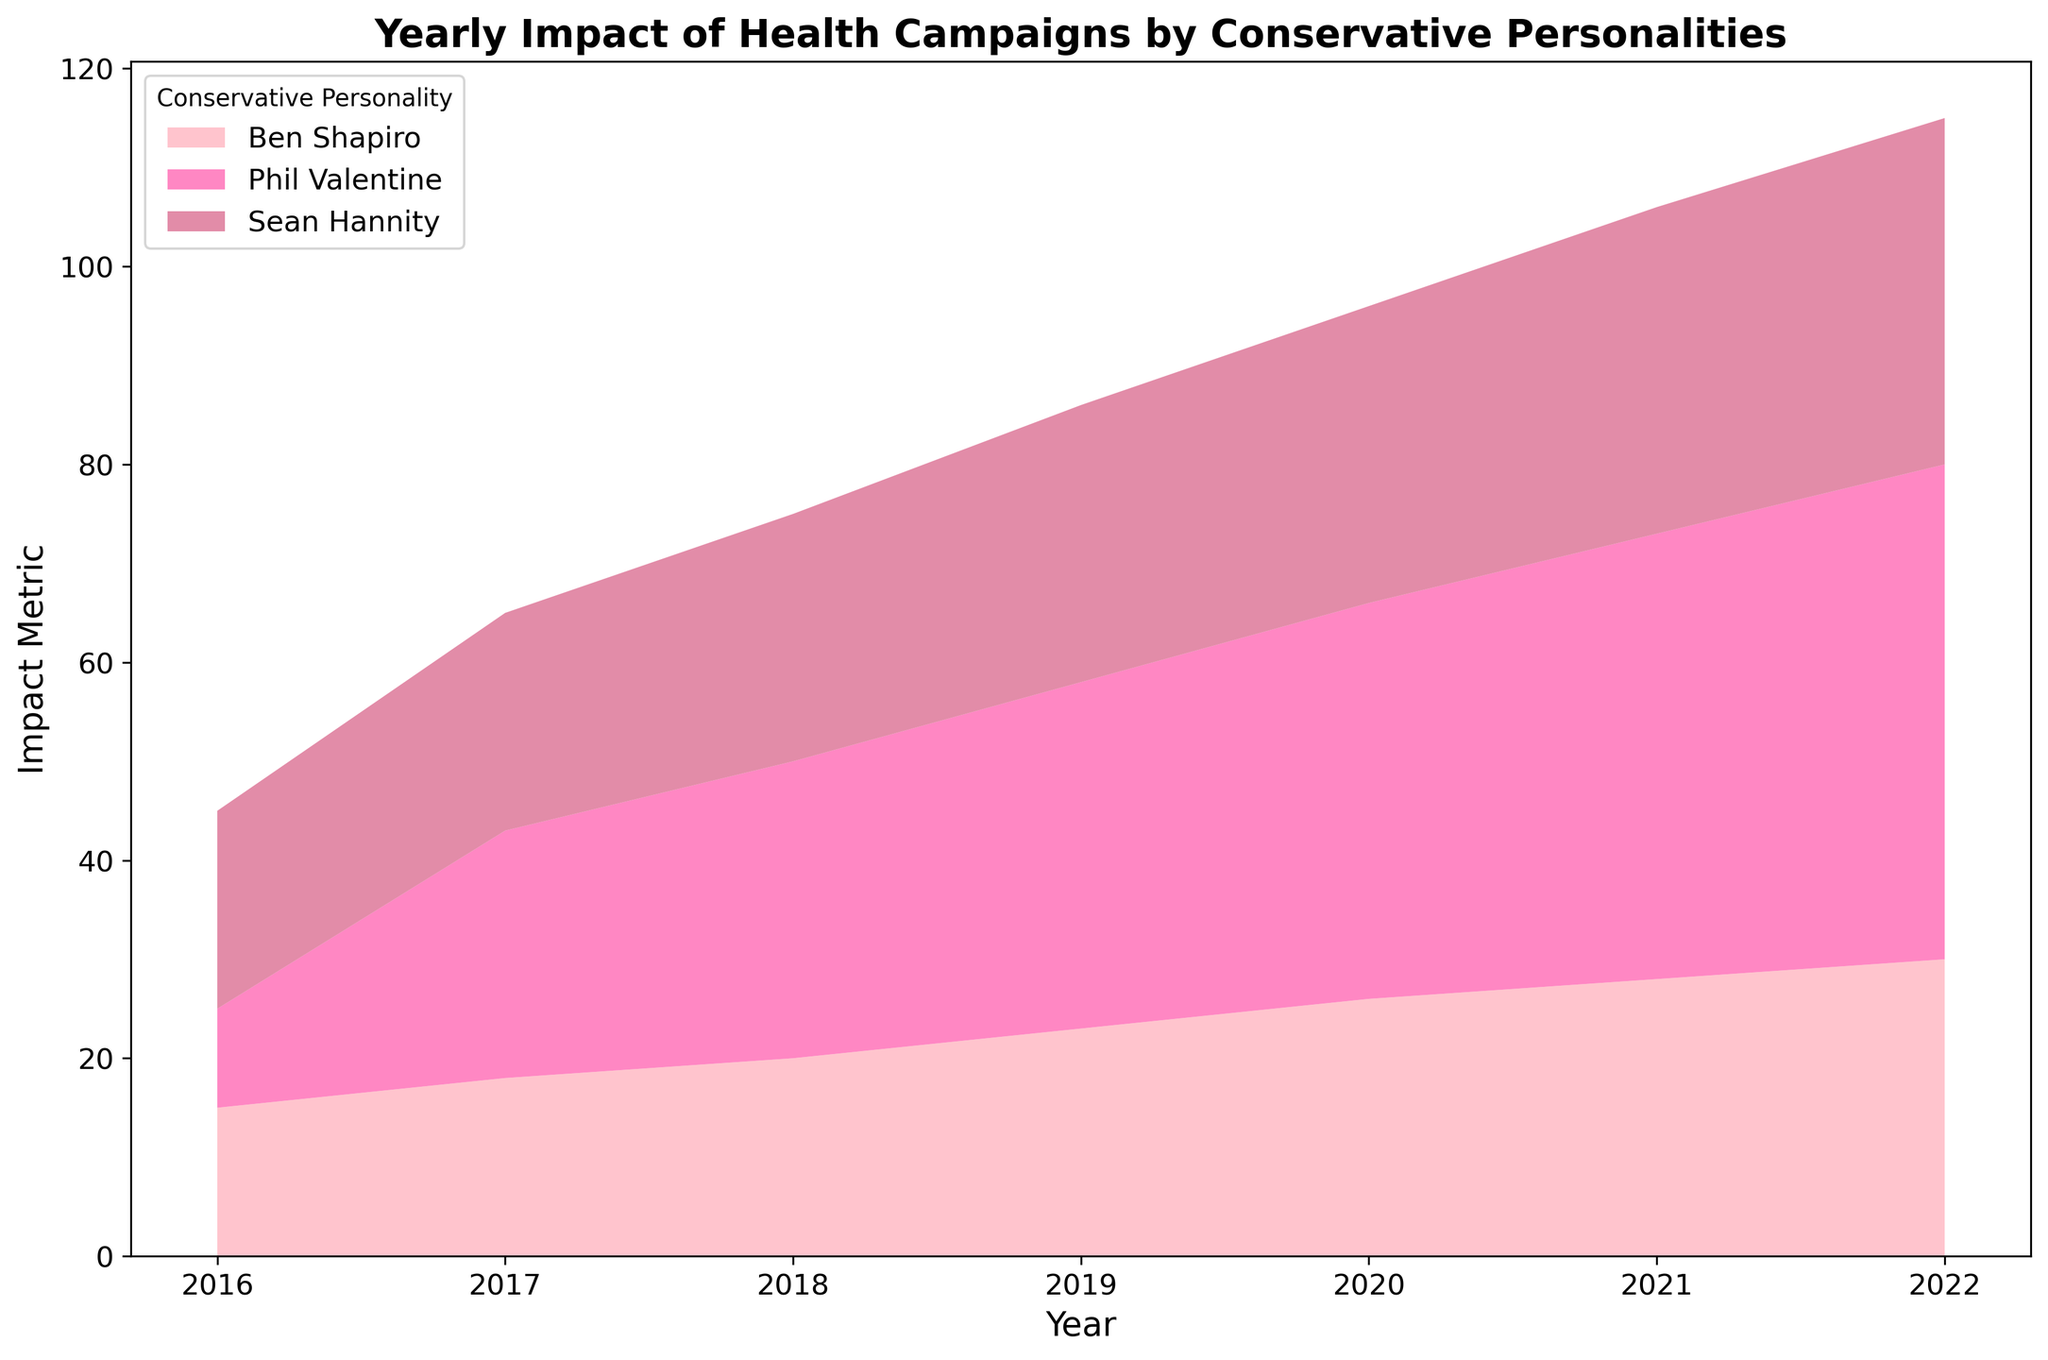What is the trend in the impact of 'Smoking Cessation' campaigns by Phil Valentine from 2016 to 2022? The 'Smoking Cessation' campaign shows a consistent increase in Phil Valentine's impact metric from 10 in 2016 to 50 in 2022. This is indicated by the ascending area corresponding to Phil Valentine over the years.
Answer: A steady increase Comparing 2020, which conservative personality had the highest impact on their respective campaign? In 2020, Phil Valentine had the highest impact with a metric of 40 for the 'Smoking Cessation' campaign. This is higher than Ben Shapiro's 26 for 'Healthy Eating' and Sean Hannity's 30 for 'Exercise Regularly.'
Answer: Phil Valentine Which conservative personality's campaign impact grew the most between 2016 and 2022? Phil Valentine's 'Smoking Cessation' campaign impact grew from 10 in 2016 to 50 in 2022. The growth is 40. Ben Shapiro's 'Healthy Eating' grew from 15 to 30, an increase of 15. Sean Hannity's 'Exercise Regularly' grew from 20 to 35, an increase of 15. Hence, Phil Valentine had the most significant growth.
Answer: Phil Valentine For which year did Sean Hannity's 'Exercise Regularly' impact show the smallest increase compared to the previous year? From 2017 to 2018, Sean Hannity's 'Exercise Regularly' campaign impact increased by only 3 (22 to 25). This is the smallest increment compared to other years where the increases were more significant.
Answer: 2018 On average, what was Phil Valentine's impact on 'Smoking Cessation' campaigns from 2016 to 2018? The impact metrics for Phil Valentine from 2016 to 2018 are 10, 25, and 30, respectively. The average is calculated as (10 + 25 + 30) / 3 = 65 / 3 ≈ 21.67.
Answer: 21.67 Which conservative personality had the highest total impact from 2016 to 2022? Summing up the impact metrics from 2016 to 2022 for each personality:
- Phil Valentine: 10 + 25 + 30 + 35 + 40 + 45 + 50 = 235
- Ben Shapiro: 15 + 18 + 20 + 23 + 26 + 28 + 30 = 160
- Sean Hannity: 20 + 22 + 25 + 28 + 30 + 33 + 35 = 193
Phil Valentine has the highest total impact of 235.
Answer: Phil Valentine In 2019, how much greater was the impact of Phil Valentine compared to Ben Shapiro? In 2019, Phil Valentine's impact was 35, and Ben Shapiro's impact was 23. The difference is 35 - 23 = 12.
Answer: 12 What is the cumulative impact of the 'Healthy Eating' campaign by Ben Shapiro from 2016 to 2022? The impact metrics for Ben Shapiro from 2016 to 2022 are 15, 18, 20, 23, 26, 28, and 30. The cumulative impact is 15 + 18 + 20 + 23 + 26 + 28 + 30 = 160.
Answer: 160 Comparing the years 2020 and 2021, which conservative personality's campaign saw the most significant increase? Comparing the years 2020 (40, 26, 30) and 2021 (45, 28, 33), the increases are:
- Phil Valentine: 45 - 40 = 5
- Ben Shapiro: 28 - 26 = 2
- Sean Hannity: 33 - 30 = 3
Phil Valentine's campaign saw the most significant increase.
Answer: Phil Valentine Which campaign consistently ranked lowest in its total impact metric across the years 2016 to 2022? Comparing totals:
- Phil Valentine's 'Smoking Cessation': 235
- Ben Shapiro's 'Healthy Eating': 160
- Sean Hannity's 'Exercise Regularly': 193
Ben Shapiro's 'Healthy Eating' had the lowest total impact.
Answer: Healthy Eating 